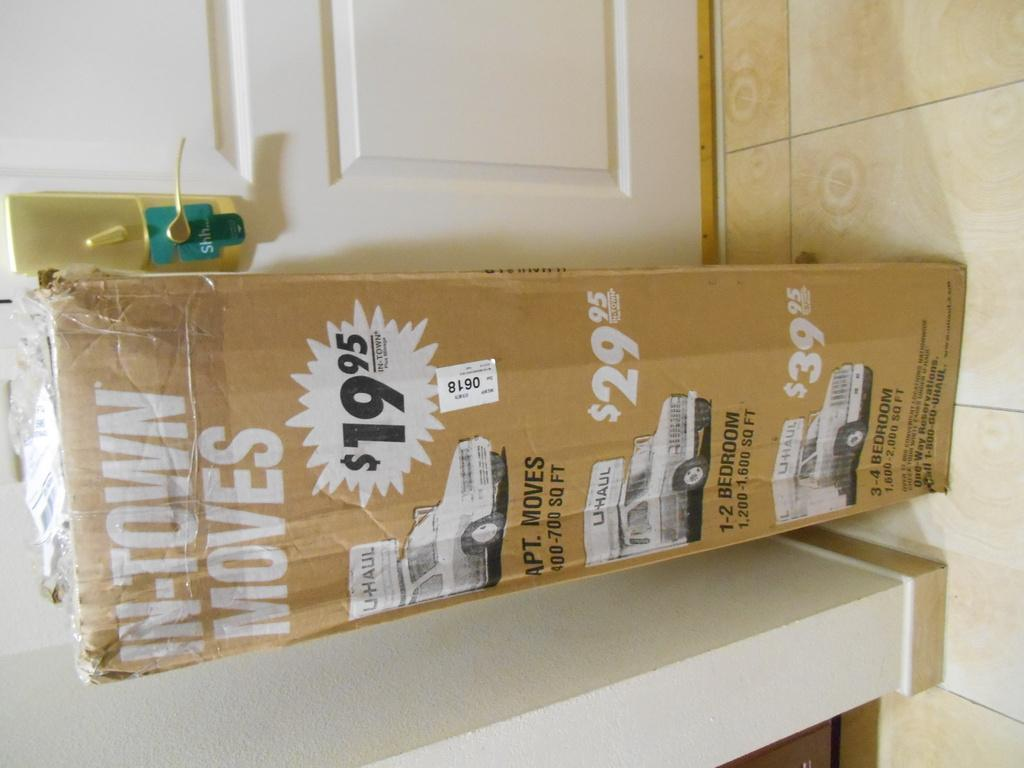Provide a one-sentence caption for the provided image. A long U haul box advertising $19.95 deals. 